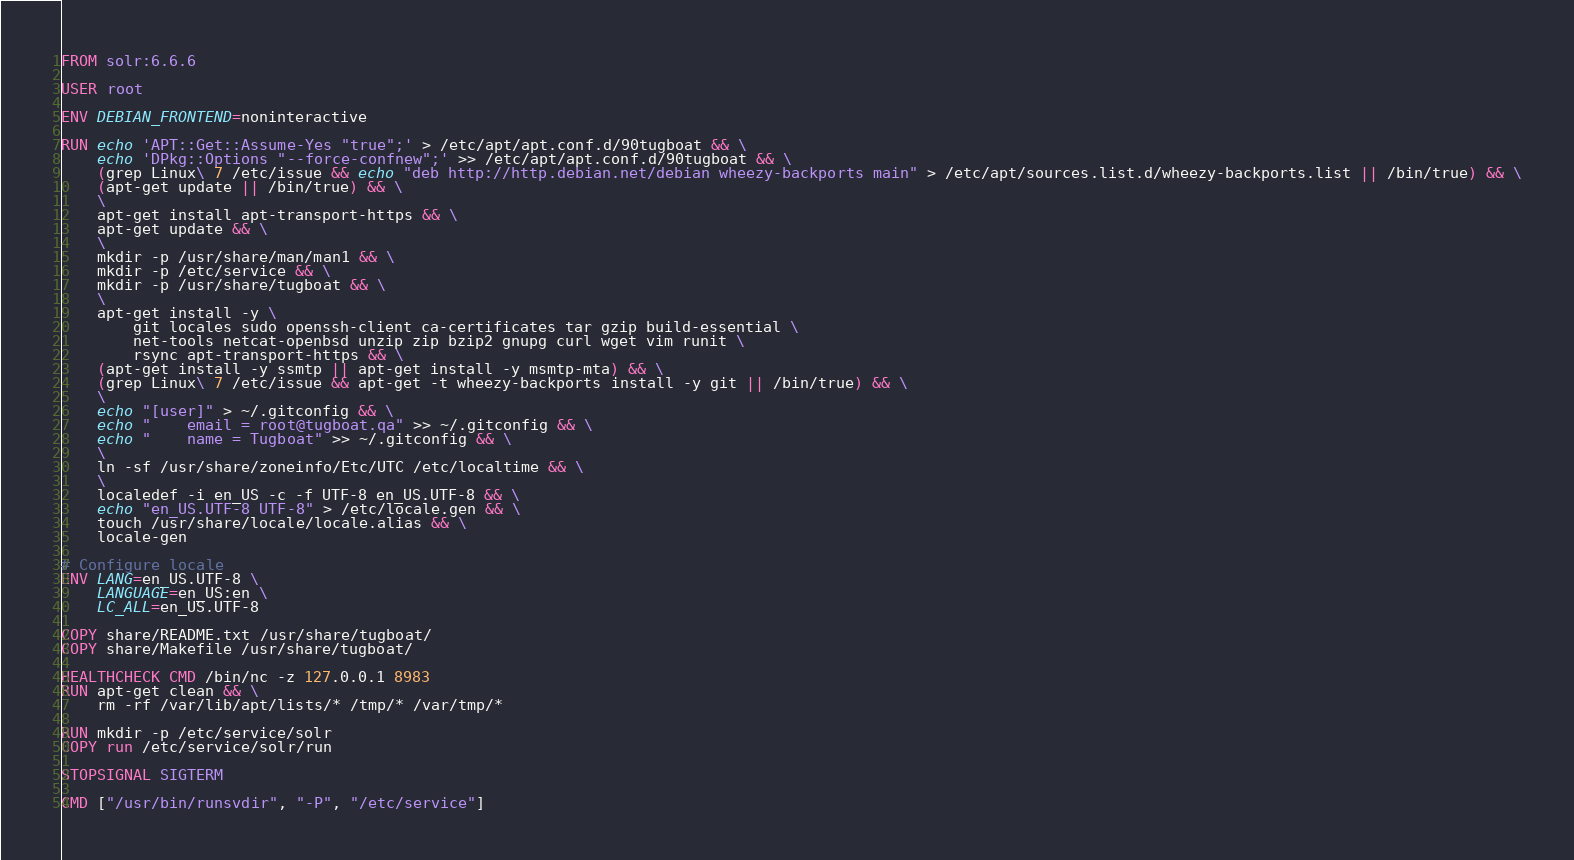<code> <loc_0><loc_0><loc_500><loc_500><_Dockerfile_>FROM solr:6.6.6

USER root

ENV DEBIAN_FRONTEND=noninteractive

RUN echo 'APT::Get::Assume-Yes "true";' > /etc/apt/apt.conf.d/90tugboat && \
    echo 'DPkg::Options "--force-confnew";' >> /etc/apt/apt.conf.d/90tugboat && \
    (grep Linux\ 7 /etc/issue && echo "deb http://http.debian.net/debian wheezy-backports main" > /etc/apt/sources.list.d/wheezy-backports.list || /bin/true) && \
    (apt-get update || /bin/true) && \
    \
    apt-get install apt-transport-https && \
    apt-get update && \
    \
    mkdir -p /usr/share/man/man1 && \
    mkdir -p /etc/service && \
    mkdir -p /usr/share/tugboat && \
    \
    apt-get install -y \
        git locales sudo openssh-client ca-certificates tar gzip build-essential \
        net-tools netcat-openbsd unzip zip bzip2 gnupg curl wget vim runit \
        rsync apt-transport-https && \
    (apt-get install -y ssmtp || apt-get install -y msmtp-mta) && \
    (grep Linux\ 7 /etc/issue && apt-get -t wheezy-backports install -y git || /bin/true) && \
    \
    echo "[user]" > ~/.gitconfig && \
    echo "    email = root@tugboat.qa" >> ~/.gitconfig && \
    echo "    name = Tugboat" >> ~/.gitconfig && \
    \
    ln -sf /usr/share/zoneinfo/Etc/UTC /etc/localtime && \
    \
    localedef -i en_US -c -f UTF-8 en_US.UTF-8 && \
    echo "en_US.UTF-8 UTF-8" > /etc/locale.gen && \
    touch /usr/share/locale/locale.alias && \
    locale-gen

# Configure locale
ENV LANG=en_US.UTF-8 \
    LANGUAGE=en_US:en \
    LC_ALL=en_US.UTF-8

COPY share/README.txt /usr/share/tugboat/
COPY share/Makefile /usr/share/tugboat/

HEALTHCHECK CMD /bin/nc -z 127.0.0.1 8983
RUN apt-get clean && \
    rm -rf /var/lib/apt/lists/* /tmp/* /var/tmp/*

RUN mkdir -p /etc/service/solr
COPY run /etc/service/solr/run

STOPSIGNAL SIGTERM

CMD ["/usr/bin/runsvdir", "-P", "/etc/service"]
</code> 